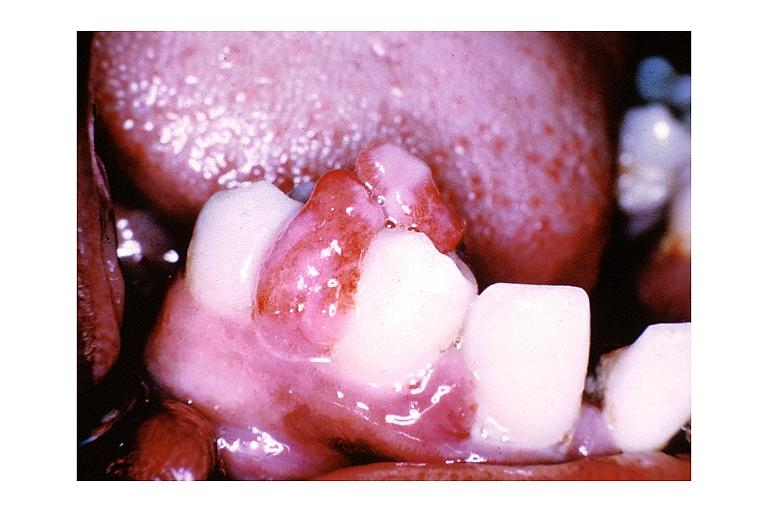s leiomyomas present?
Answer the question using a single word or phrase. No 